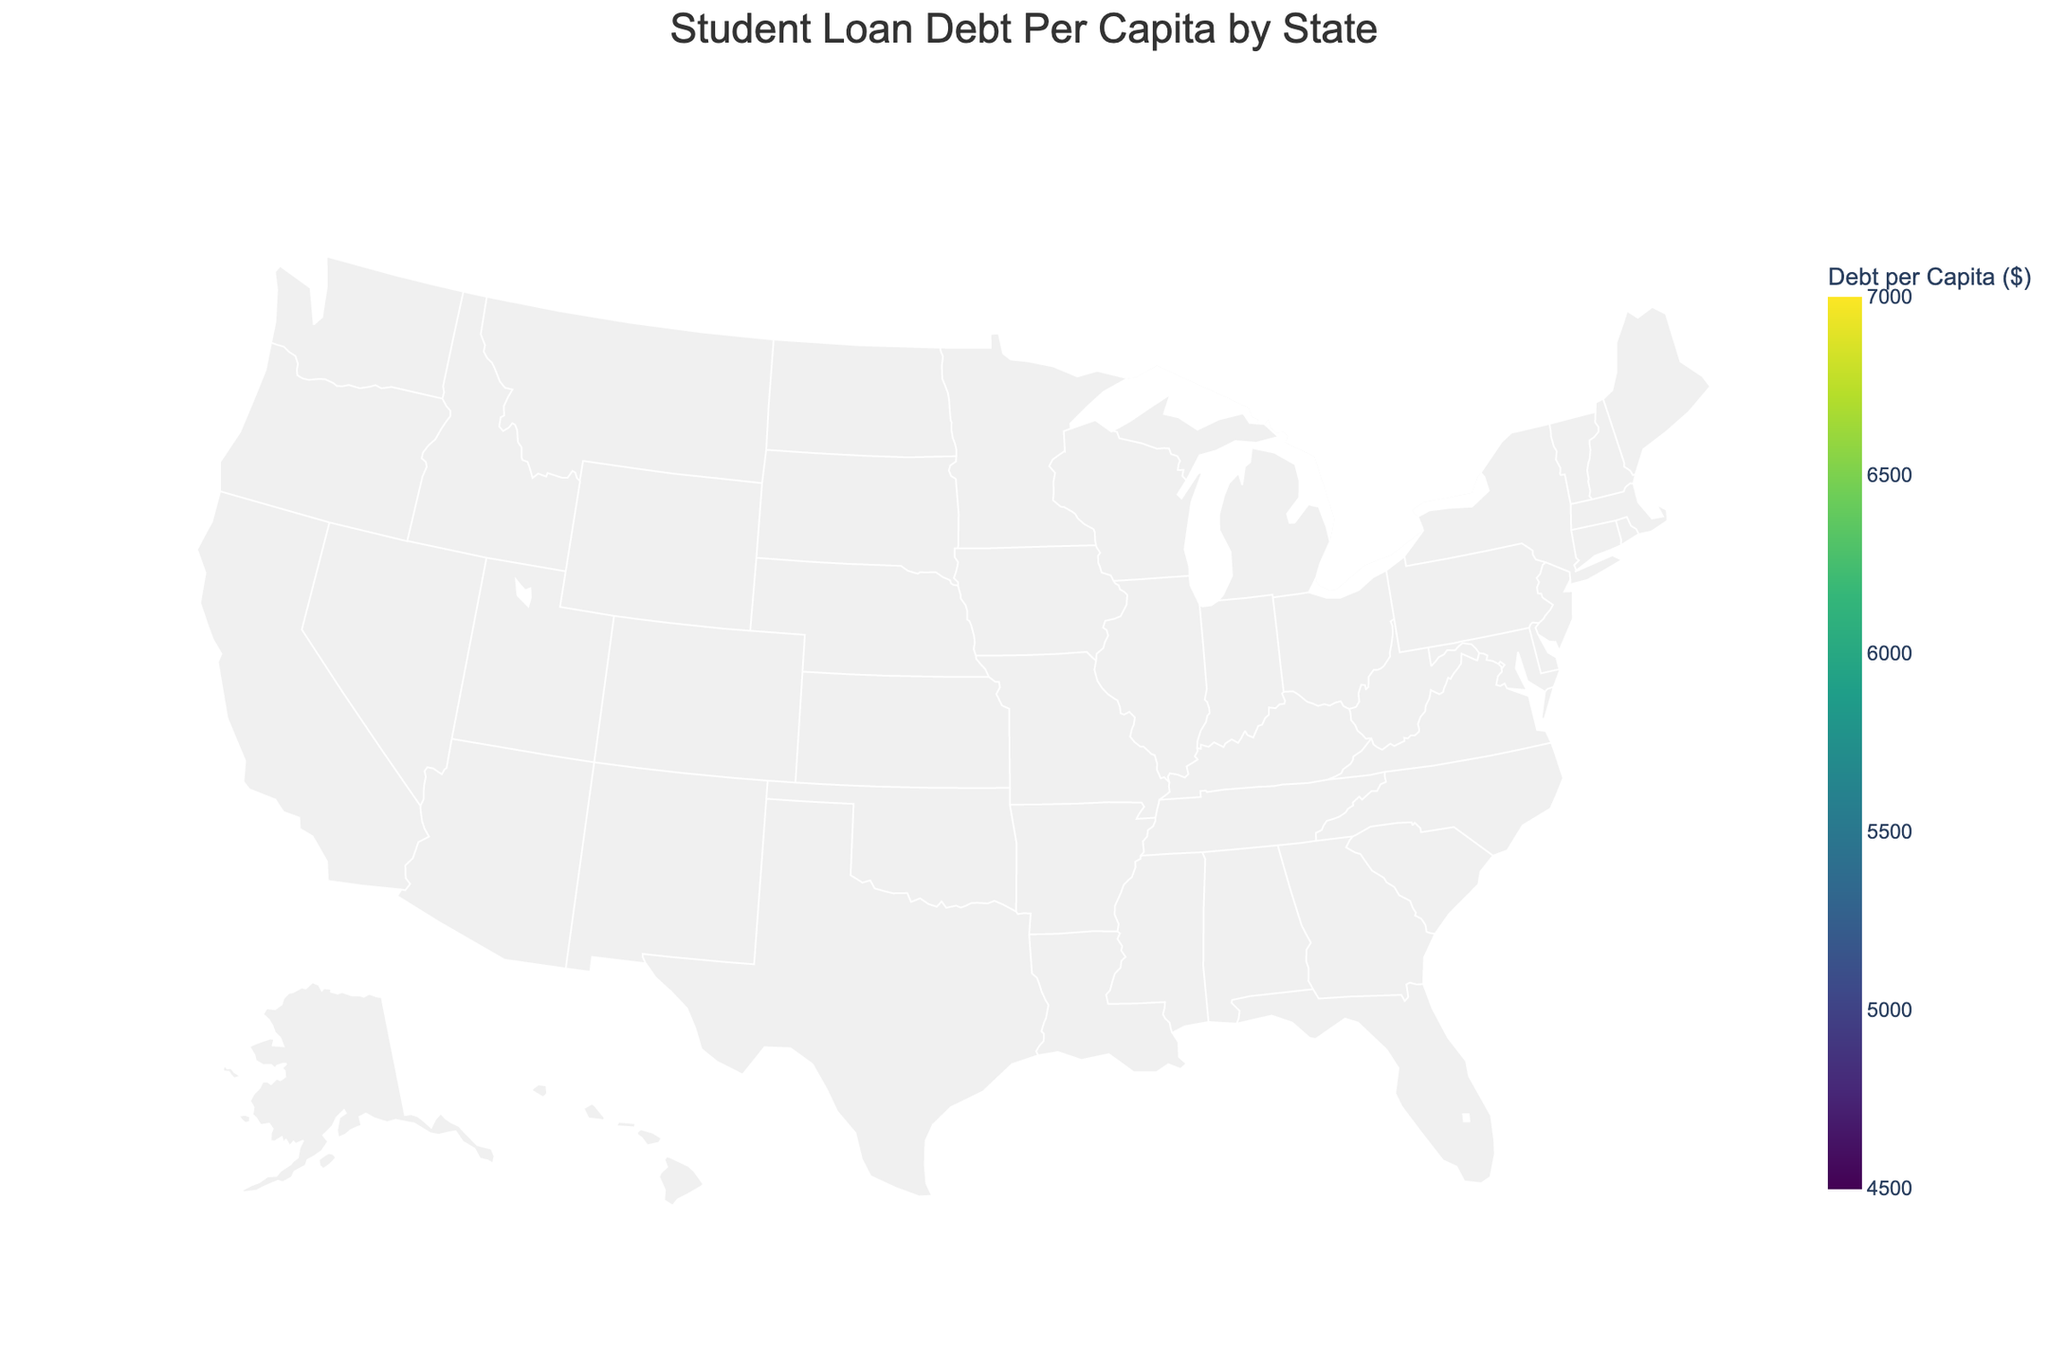What is the title of the figure? The title of the figure is located at the top and usually summarizes what the plot is about. In this case, the title plainly states "Student Loan Debt Per Capita by State" which gives an insight into what the map represents.
Answer: Student Loan Debt Per Capita by State Which state has the highest student loan debt per capita? The color coding on the figure helps us identify which states have the highest values. Massachusetts is the darkest shade, indicating it has the highest student loan debt per capita.
Answer: Massachusetts What's the range of the color scale used in the figure? The color scale represents the range of student loan debt per capita and is shown in the legend. The figure's range is from 4500 to 7000 dollars.
Answer: 4500 to 7000 dollars How is the student loan debt per capita distributed geographically? By observing the color gradation over the states, it’s apparent that higher debts are concentrated in the Northeast, while lower debts are more common in the Midwest and a few Southern states.
Answer: Higher in the Northeast, lower in the Midwest and South What's the approximate student loan debt per capita for California? California is a lighter shade on the map compared to some other states, indicating a lower debt. Referring to the color scale, California's approximate debt per capita is around 5480 dollars.
Answer: Approximately 5480 dollars Which states have student loan debt per capita over 6000 dollars? States over the 6000-dollar mark can be identified by their darker shades. Massachusetts, New York, Minnesota, Colorado, Georgia, Virginia, and Pennsylvania are in this category.
Answer: Massachusetts, New York, Minnesota, Colorado, Georgia, Virginia, Pennsylvania Compare the student loan debt per capita between New York and Ohio. By comparing the shades of New York and Ohio on the map and cross-referencing with the color scale, we see that New York has a higher debt per capita (6730 dollars) compared to Ohio (5890 dollars).
Answer: New York has a higher debt What’s the median student loan debt per capita value from the dataset? To find the median, list all the entries and find the middle value. Sorting the given data: 4920, 5080, 5150, 5190, 5230, 5250, 5310, 5340, 5420, 5480, 5680, 5760, 5820, 5890, 5970, 6080, 6120, 6150, 6210, 6340, 6410, 6730, 6890. With 23 states, the median is the 12th value: 5760 dollars.
Answer: 5760 dollars Is there a correlation between geographic location and student loan debt per capita? By examining the geographic distribution of the shades, we can infer a pattern. States in the Northeast tend to show higher debt per capita, hinting at some correlation between geographic location and student loan debt levels.
Answer: Yes, particularly higher in the Northeast If you were to calculate the average student loan debt per capita using the data provided, what process would you follow? Sum all the student loan debt values and divide by the total number of states. Sum = 5480 + 4920 + 6730 + 6210 + 5890 + 5760 + 5340 + 6120 + 5230 + 5680 + 5420 + 5150 + 5310 + 5080 + 5190 + 6340 + 5970 + 5820 + 6890 + 5250 + 6080 + 6410 + 6150 = 137,190. Average = 137,190 / 23 ≈ 5965.65 dollars.
Answer: Approximately 5966 dollars 